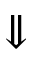<formula> <loc_0><loc_0><loc_500><loc_500>\Downarrow</formula> 